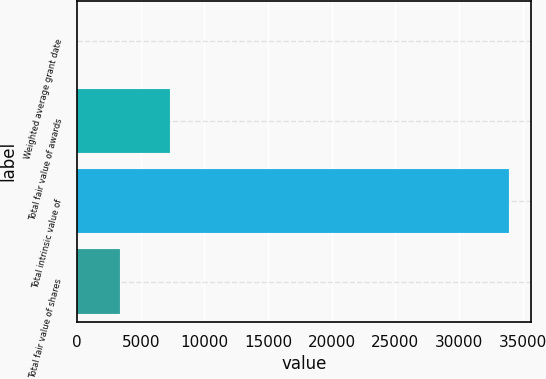<chart> <loc_0><loc_0><loc_500><loc_500><bar_chart><fcel>Weighted average grant date<fcel>Total fair value of awards<fcel>Total intrinsic value of<fcel>Total fair value of shares<nl><fcel>11.52<fcel>7281<fcel>33920<fcel>3402.37<nl></chart> 